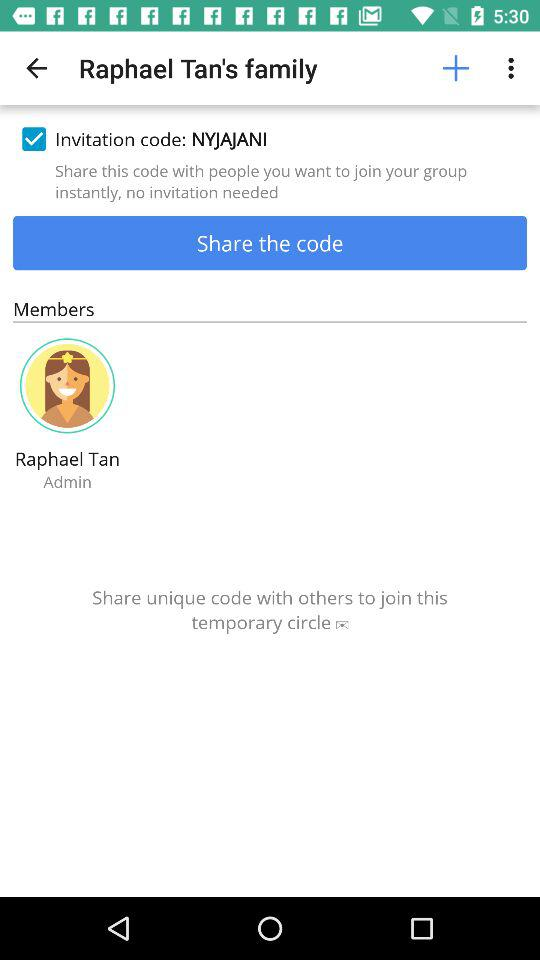Who is the admin? The admin is Raphael Tan. 